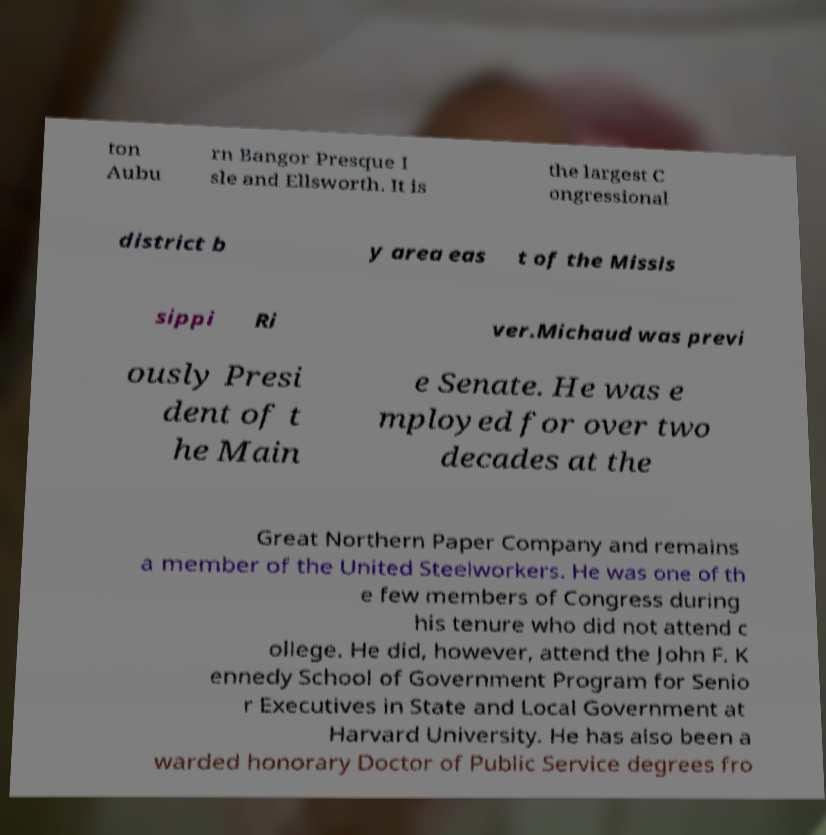Can you accurately transcribe the text from the provided image for me? ton Aubu rn Bangor Presque I sle and Ellsworth. It is the largest C ongressional district b y area eas t of the Missis sippi Ri ver.Michaud was previ ously Presi dent of t he Main e Senate. He was e mployed for over two decades at the Great Northern Paper Company and remains a member of the United Steelworkers. He was one of th e few members of Congress during his tenure who did not attend c ollege. He did, however, attend the John F. K ennedy School of Government Program for Senio r Executives in State and Local Government at Harvard University. He has also been a warded honorary Doctor of Public Service degrees fro 